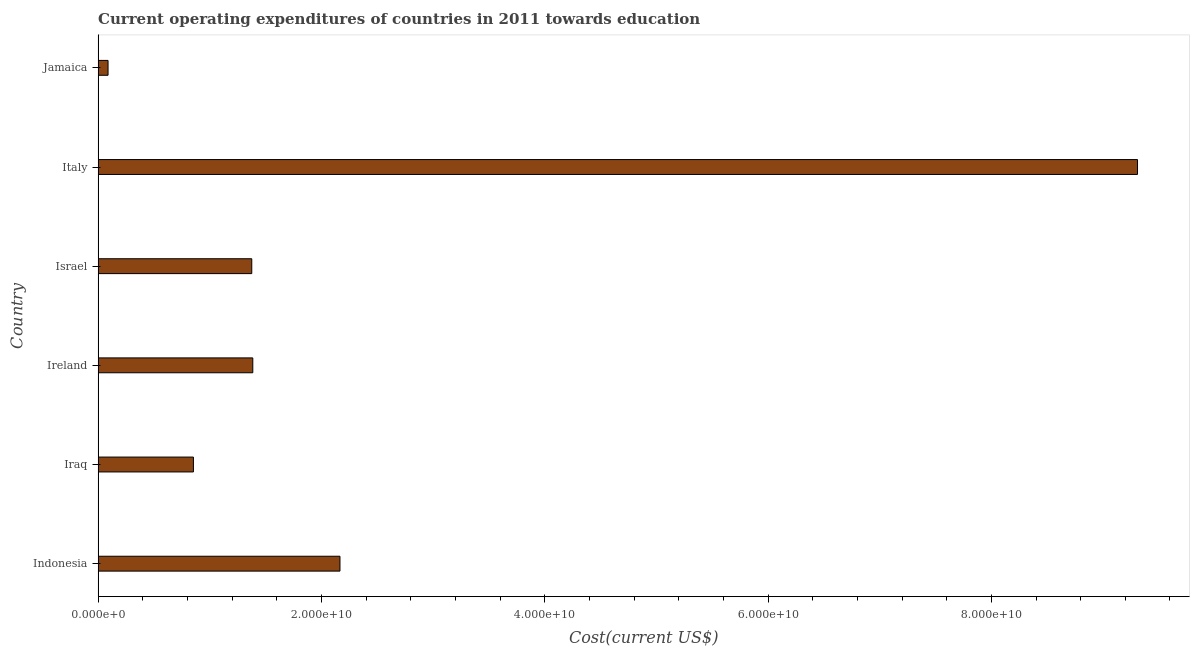Does the graph contain any zero values?
Make the answer very short. No. What is the title of the graph?
Your response must be concise. Current operating expenditures of countries in 2011 towards education. What is the label or title of the X-axis?
Your answer should be very brief. Cost(current US$). What is the education expenditure in Ireland?
Provide a succinct answer. 1.39e+1. Across all countries, what is the maximum education expenditure?
Your answer should be very brief. 9.31e+1. Across all countries, what is the minimum education expenditure?
Keep it short and to the point. 8.89e+08. In which country was the education expenditure maximum?
Your response must be concise. Italy. In which country was the education expenditure minimum?
Give a very brief answer. Jamaica. What is the sum of the education expenditure?
Make the answer very short. 1.52e+11. What is the difference between the education expenditure in Indonesia and Italy?
Provide a succinct answer. -7.14e+1. What is the average education expenditure per country?
Offer a very short reply. 2.53e+1. What is the median education expenditure?
Your answer should be very brief. 1.38e+1. What is the ratio of the education expenditure in Ireland to that in Italy?
Your answer should be very brief. 0.15. Is the education expenditure in Ireland less than that in Israel?
Your response must be concise. No. What is the difference between the highest and the second highest education expenditure?
Offer a terse response. 7.14e+1. Is the sum of the education expenditure in Iraq and Ireland greater than the maximum education expenditure across all countries?
Offer a very short reply. No. What is the difference between the highest and the lowest education expenditure?
Provide a short and direct response. 9.22e+1. In how many countries, is the education expenditure greater than the average education expenditure taken over all countries?
Provide a succinct answer. 1. How many bars are there?
Your answer should be very brief. 6. Are all the bars in the graph horizontal?
Offer a very short reply. Yes. How many countries are there in the graph?
Your response must be concise. 6. What is the Cost(current US$) in Indonesia?
Offer a terse response. 2.17e+1. What is the Cost(current US$) in Iraq?
Offer a very short reply. 8.54e+09. What is the Cost(current US$) of Ireland?
Keep it short and to the point. 1.39e+1. What is the Cost(current US$) of Israel?
Your answer should be compact. 1.38e+1. What is the Cost(current US$) of Italy?
Give a very brief answer. 9.31e+1. What is the Cost(current US$) in Jamaica?
Provide a short and direct response. 8.89e+08. What is the difference between the Cost(current US$) in Indonesia and Iraq?
Your answer should be very brief. 1.31e+1. What is the difference between the Cost(current US$) in Indonesia and Ireland?
Offer a terse response. 7.81e+09. What is the difference between the Cost(current US$) in Indonesia and Israel?
Keep it short and to the point. 7.90e+09. What is the difference between the Cost(current US$) in Indonesia and Italy?
Your answer should be very brief. -7.14e+1. What is the difference between the Cost(current US$) in Indonesia and Jamaica?
Give a very brief answer. 2.08e+1. What is the difference between the Cost(current US$) in Iraq and Ireland?
Ensure brevity in your answer.  -5.32e+09. What is the difference between the Cost(current US$) in Iraq and Israel?
Offer a very short reply. -5.23e+09. What is the difference between the Cost(current US$) in Iraq and Italy?
Ensure brevity in your answer.  -8.46e+1. What is the difference between the Cost(current US$) in Iraq and Jamaica?
Provide a succinct answer. 7.65e+09. What is the difference between the Cost(current US$) in Ireland and Israel?
Give a very brief answer. 9.23e+07. What is the difference between the Cost(current US$) in Ireland and Italy?
Make the answer very short. -7.92e+1. What is the difference between the Cost(current US$) in Ireland and Jamaica?
Keep it short and to the point. 1.30e+1. What is the difference between the Cost(current US$) in Israel and Italy?
Your answer should be compact. -7.93e+1. What is the difference between the Cost(current US$) in Israel and Jamaica?
Your answer should be compact. 1.29e+1. What is the difference between the Cost(current US$) in Italy and Jamaica?
Make the answer very short. 9.22e+1. What is the ratio of the Cost(current US$) in Indonesia to that in Iraq?
Keep it short and to the point. 2.54. What is the ratio of the Cost(current US$) in Indonesia to that in Ireland?
Provide a succinct answer. 1.56. What is the ratio of the Cost(current US$) in Indonesia to that in Israel?
Provide a succinct answer. 1.57. What is the ratio of the Cost(current US$) in Indonesia to that in Italy?
Give a very brief answer. 0.23. What is the ratio of the Cost(current US$) in Indonesia to that in Jamaica?
Ensure brevity in your answer.  24.36. What is the ratio of the Cost(current US$) in Iraq to that in Ireland?
Provide a short and direct response. 0.62. What is the ratio of the Cost(current US$) in Iraq to that in Israel?
Make the answer very short. 0.62. What is the ratio of the Cost(current US$) in Iraq to that in Italy?
Your answer should be very brief. 0.09. What is the ratio of the Cost(current US$) in Iraq to that in Jamaica?
Provide a short and direct response. 9.6. What is the ratio of the Cost(current US$) in Ireland to that in Italy?
Your answer should be compact. 0.15. What is the ratio of the Cost(current US$) in Ireland to that in Jamaica?
Provide a short and direct response. 15.58. What is the ratio of the Cost(current US$) in Israel to that in Italy?
Ensure brevity in your answer.  0.15. What is the ratio of the Cost(current US$) in Israel to that in Jamaica?
Offer a very short reply. 15.47. What is the ratio of the Cost(current US$) in Italy to that in Jamaica?
Your answer should be compact. 104.67. 